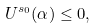Convert formula to latex. <formula><loc_0><loc_0><loc_500><loc_500>U ^ { s _ { 0 } } ( \alpha ) \leq 0 ,</formula> 